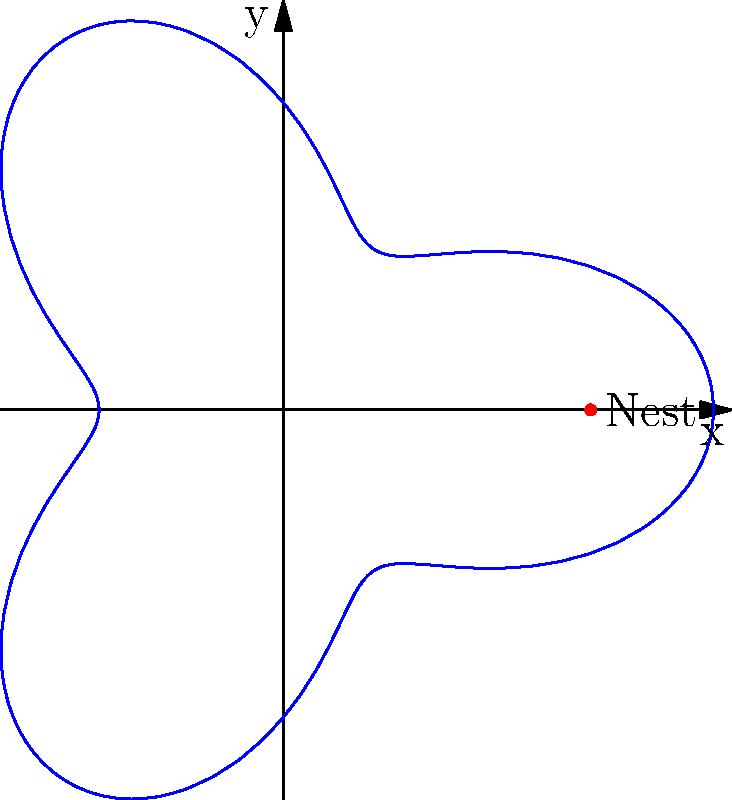A fruit bat's flight path around its nest is represented by the polar equation $r = 5 + 2\cos(3\theta)$, where $r$ is in kilometers. What is the maximum distance, in kilometers, that the fruit bat flies from its nest? To find the maximum distance the fruit bat flies from its nest, we need to follow these steps:

1) The general equation given is $r = 5 + 2\cos(3\theta)$.

2) The maximum value of $r$ will occur when $\cos(3\theta)$ is at its maximum.

3) We know that the maximum value of cosine is 1.

4) So, the maximum value of $r$ will be when $2\cos(3\theta) = 2$.

5) Substituting this into our original equation:

   $r_{max} = 5 + 2 = 7$

6) Therefore, the maximum distance the fruit bat flies from its nest is 7 kilometers.
Answer: 7 km 